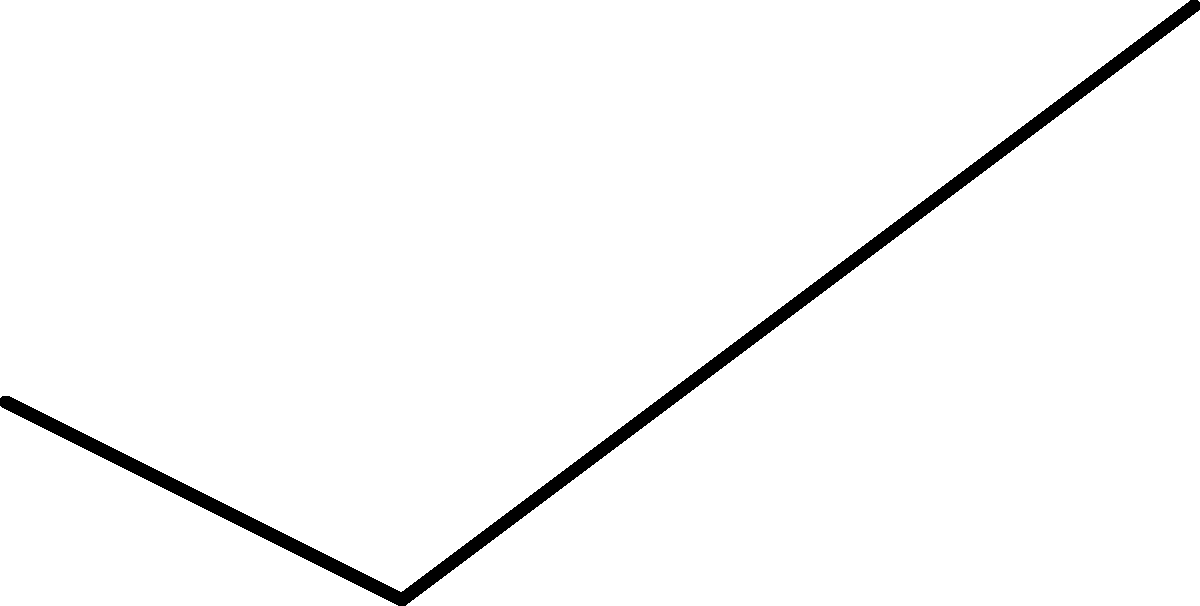In a professional boxing match, you observe a boxer throwing an uppercut. The trajectory of the punch forms an angle with the horizontal plane. Given that the boxer's shoulder is at (0,0), the elbow is at (20,-10), and the fist ends at (60,20) in a 2D coordinate system (all measurements in inches), what is the angle $\theta$ of the punch trajectory from the elbow to the fist, measured from the horizontal? To solve this problem, we'll use trigonometry and vector calculations:

1. First, let's calculate the vector from the elbow to the fist:
   Elbow coordinates: (20, -10)
   Fist coordinates: (60, 20)
   Vector = (60-20, 20-(-10)) = (40, 30)

2. The angle can be calculated using the arctangent function:
   $\theta = \arctan(\frac{y}{x})$

3. Substitute the values:
   $\theta = \arctan(\frac{30}{40})$

4. Simplify:
   $\theta = \arctan(0.75)$

5. Calculate the result:
   $\theta \approx 36.87°$

6. Round to the nearest degree:
   $\theta \approx 37°$

This angle represents the trajectory of the uppercut from the horizontal plane, measured from the elbow to the fist.
Answer: 37° 